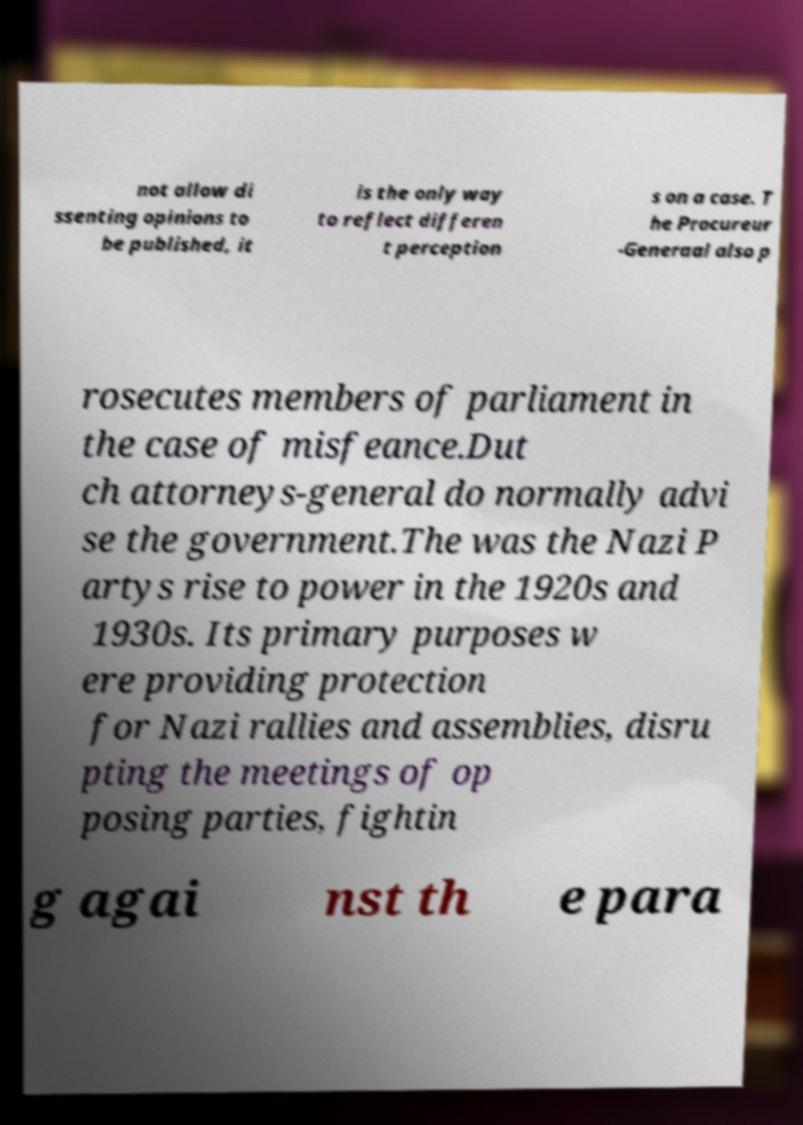Please identify and transcribe the text found in this image. not allow di ssenting opinions to be published, it is the only way to reflect differen t perception s on a case. T he Procureur -Generaal also p rosecutes members of parliament in the case of misfeance.Dut ch attorneys-general do normally advi se the government.The was the Nazi P artys rise to power in the 1920s and 1930s. Its primary purposes w ere providing protection for Nazi rallies and assemblies, disru pting the meetings of op posing parties, fightin g agai nst th e para 